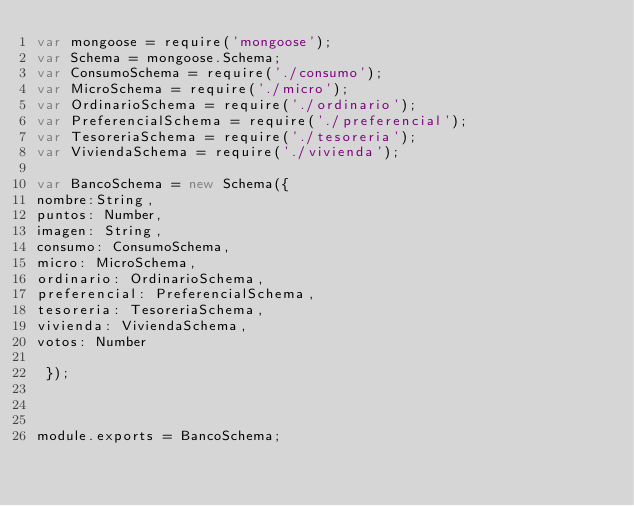Convert code to text. <code><loc_0><loc_0><loc_500><loc_500><_JavaScript_>var mongoose = require('mongoose');
var Schema = mongoose.Schema;
var ConsumoSchema = require('./consumo');
var MicroSchema = require('./micro');
var OrdinarioSchema = require('./ordinario');
var PreferencialSchema = require('./preferencial');
var TesoreriaSchema = require('./tesoreria');
var ViviendaSchema = require('./vivienda');

var BancoSchema = new Schema({
nombre:String,
puntos: Number,
imagen: String,
consumo: ConsumoSchema,
micro: MicroSchema,
ordinario: OrdinarioSchema,
preferencial: PreferencialSchema,
tesoreria: TesoreriaSchema,
vivienda: ViviendaSchema,
votos: Number

 });



module.exports = BancoSchema;
</code> 